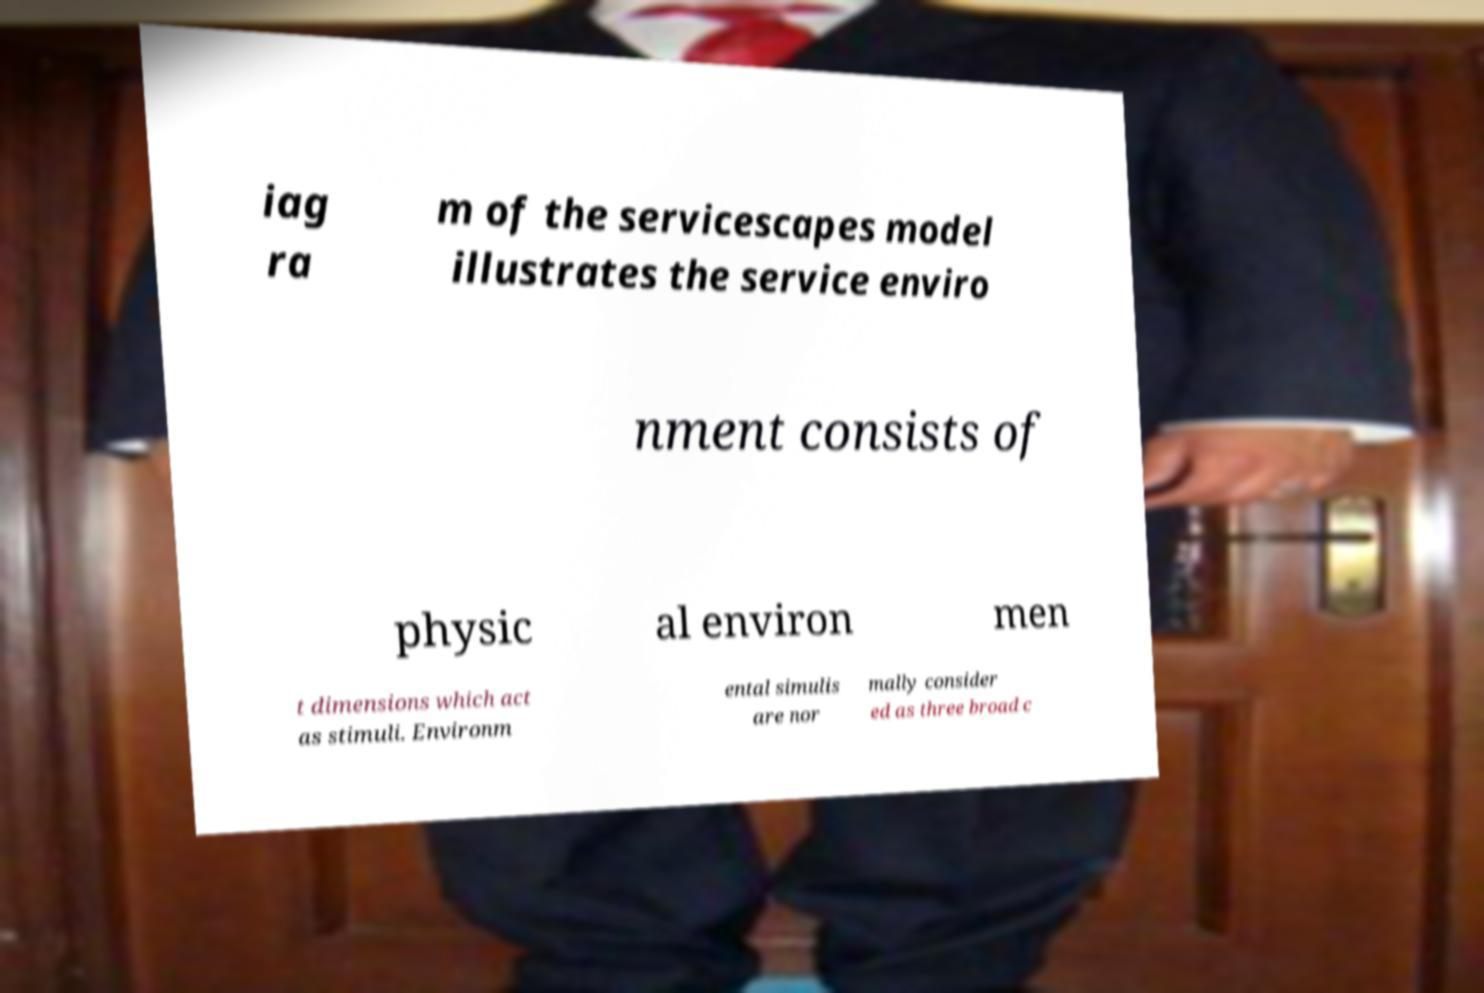Could you extract and type out the text from this image? iag ra m of the servicescapes model illustrates the service enviro nment consists of physic al environ men t dimensions which act as stimuli. Environm ental simulis are nor mally consider ed as three broad c 